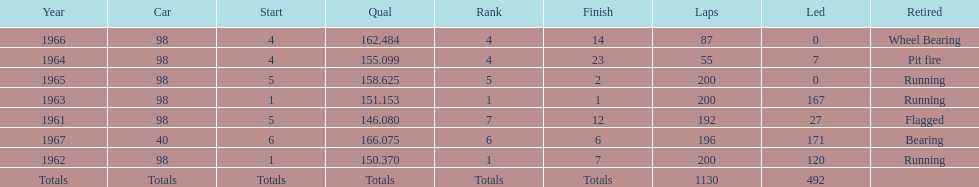How often should the races be finished by running? 3. 